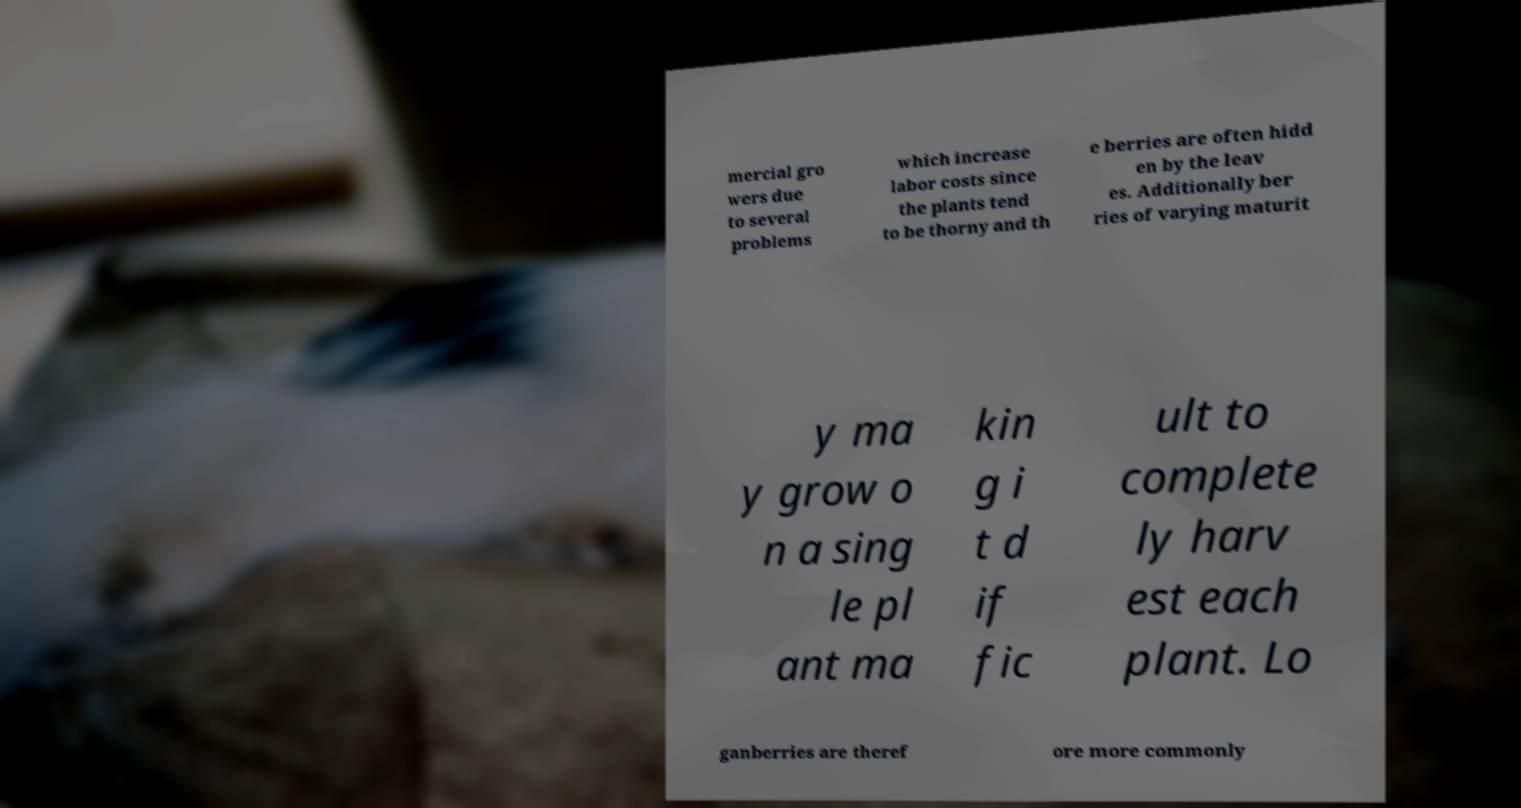Can you accurately transcribe the text from the provided image for me? mercial gro wers due to several problems which increase labor costs since the plants tend to be thorny and th e berries are often hidd en by the leav es. Additionally ber ries of varying maturit y ma y grow o n a sing le pl ant ma kin g i t d if fic ult to complete ly harv est each plant. Lo ganberries are theref ore more commonly 